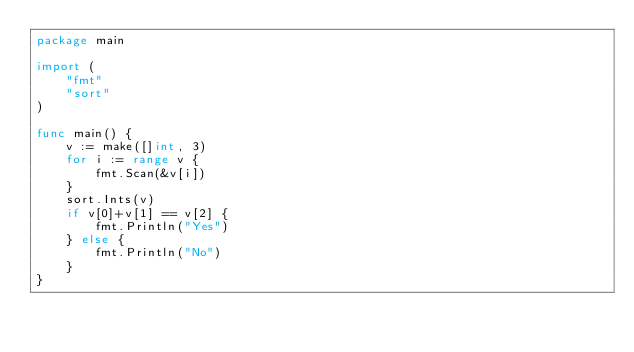<code> <loc_0><loc_0><loc_500><loc_500><_Go_>package main

import (
	"fmt"
	"sort"
)

func main() {
	v := make([]int, 3)
	for i := range v {
		fmt.Scan(&v[i])
	}
	sort.Ints(v)
	if v[0]+v[1] == v[2] {
		fmt.Println("Yes")
	} else {
		fmt.Println("No")
	}
}
</code> 